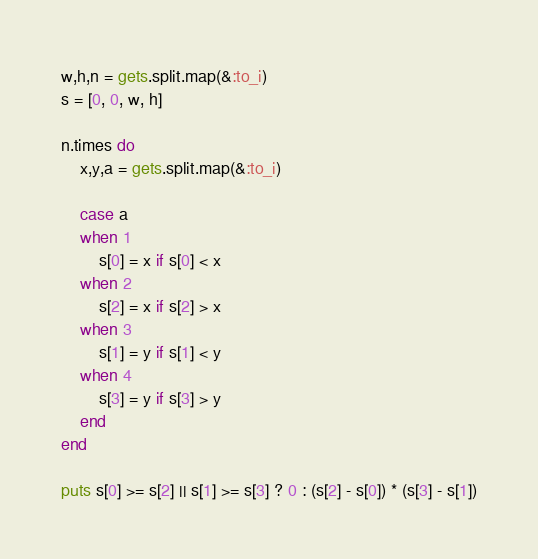Convert code to text. <code><loc_0><loc_0><loc_500><loc_500><_Ruby_>w,h,n = gets.split.map(&:to_i)
s = [0, 0, w, h]

n.times do
    x,y,a = gets.split.map(&:to_i)

    case a
    when 1
        s[0] = x if s[0] < x
    when 2
        s[2] = x if s[2] > x
    when 3
        s[1] = y if s[1] < y
    when 4
        s[3] = y if s[3] > y
    end
end

puts s[0] >= s[2] || s[1] >= s[3] ? 0 : (s[2] - s[0]) * (s[3] - s[1])</code> 